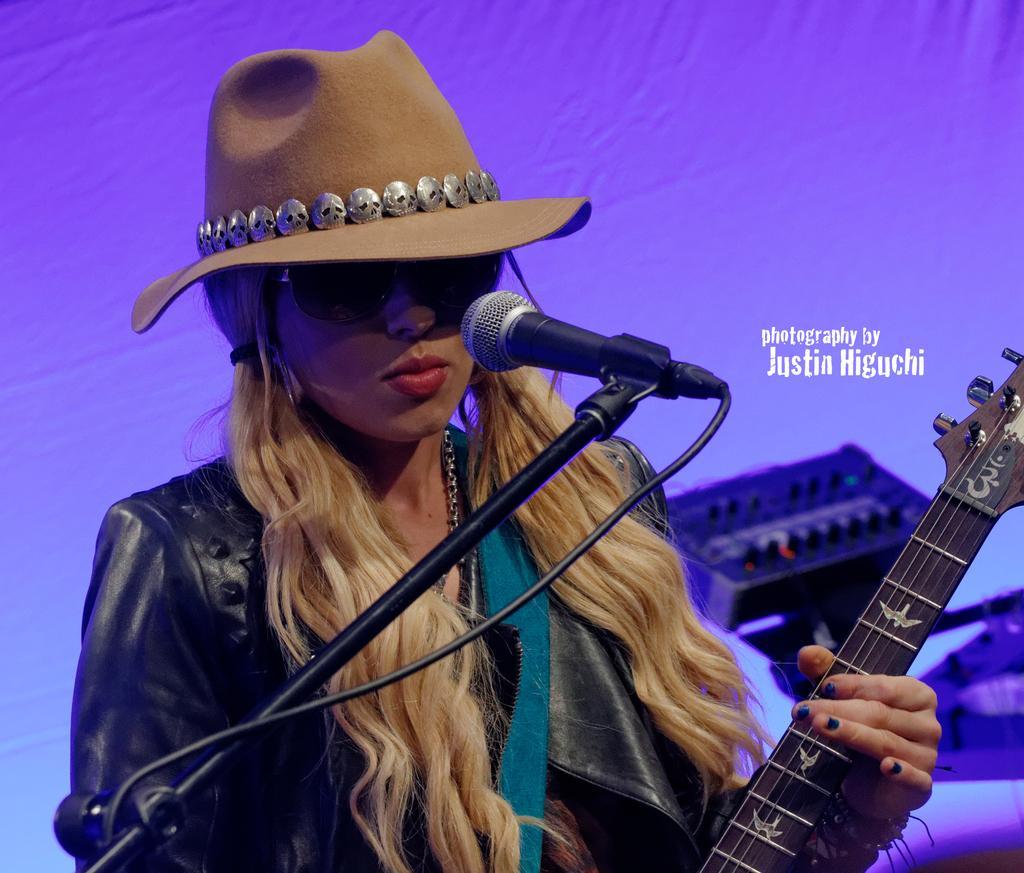How would you summarize this image in a sentence or two? In this picture there is a girl who is standing in front of the mic by holding a guitar in her hands, the girl is wearing a hat and at the right side of the image there is a music instrument. 